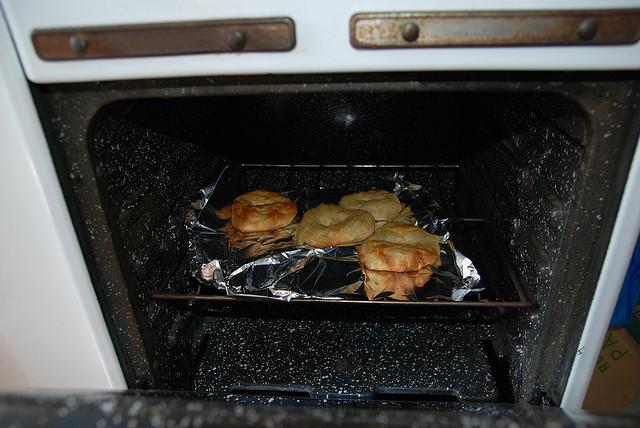What is safest to touch without being burned?

Choices:
A) foil
B) inside stove
C) food
D) pan foil 